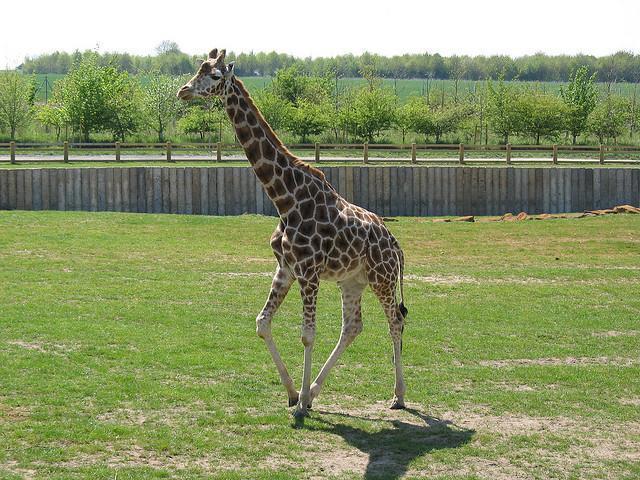How many giraffes are there?
Give a very brief answer. 1. 